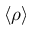Convert formula to latex. <formula><loc_0><loc_0><loc_500><loc_500>\langle \rho \rangle</formula> 